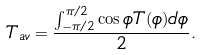Convert formula to latex. <formula><loc_0><loc_0><loc_500><loc_500>T _ { a v } = \frac { \int _ { - \pi / 2 } ^ { \pi / 2 } \cos \phi T ( \phi ) d \phi } { 2 } .</formula> 